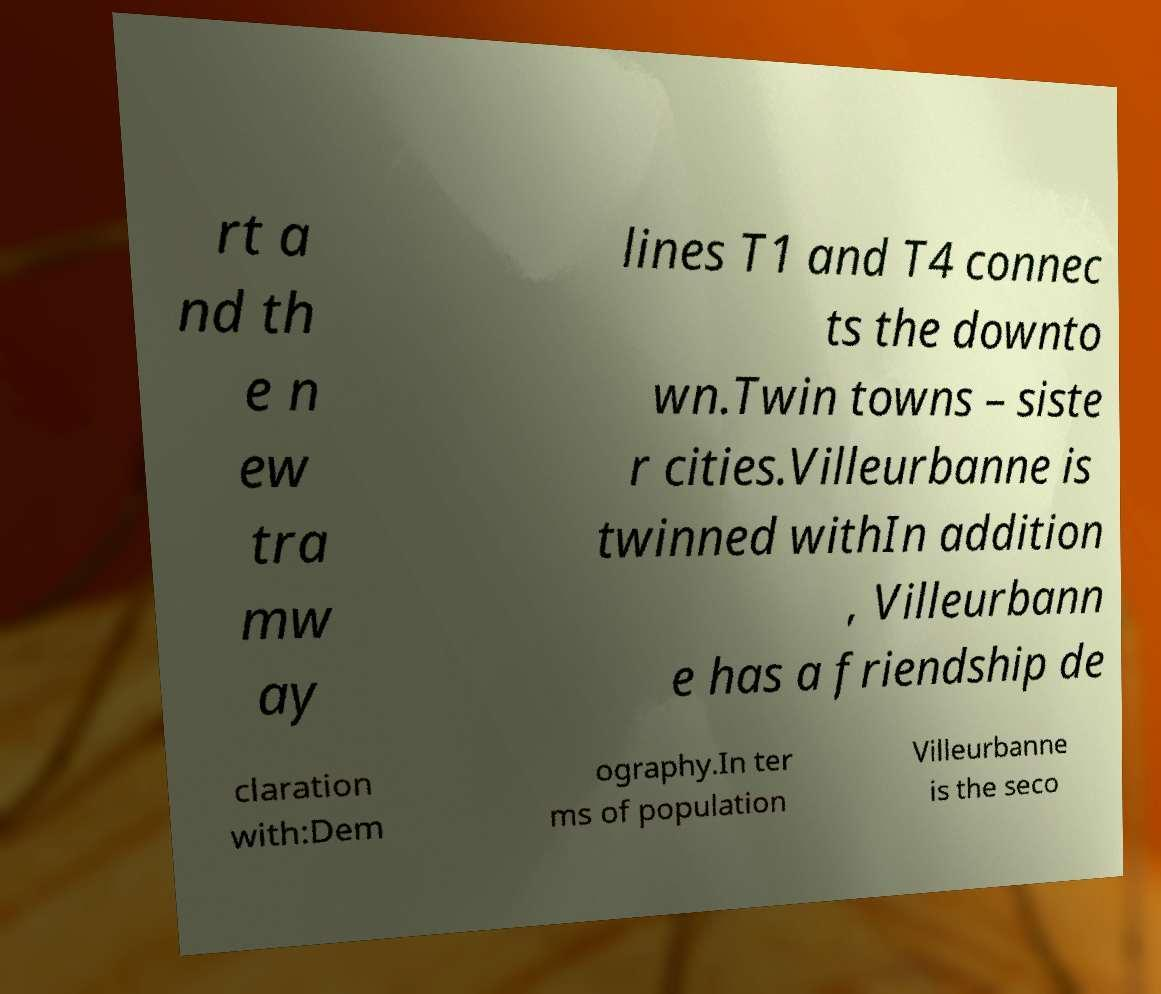I need the written content from this picture converted into text. Can you do that? rt a nd th e n ew tra mw ay lines T1 and T4 connec ts the downto wn.Twin towns – siste r cities.Villeurbanne is twinned withIn addition , Villeurbann e has a friendship de claration with:Dem ography.In ter ms of population Villeurbanne is the seco 